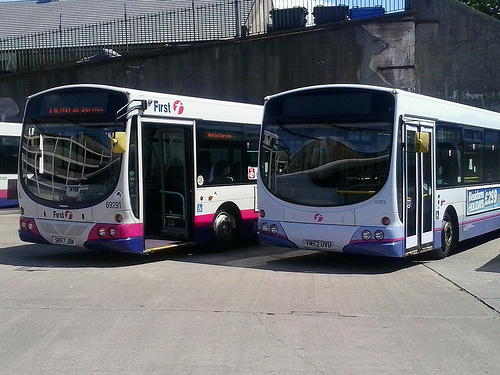What does the color scheme and branding on the buses convey? The color scheme and branding on the buses signify that they belong to a specific transportation company. They serve as visual identifiers for passengers and also function as part of the company's marketing and public image. 